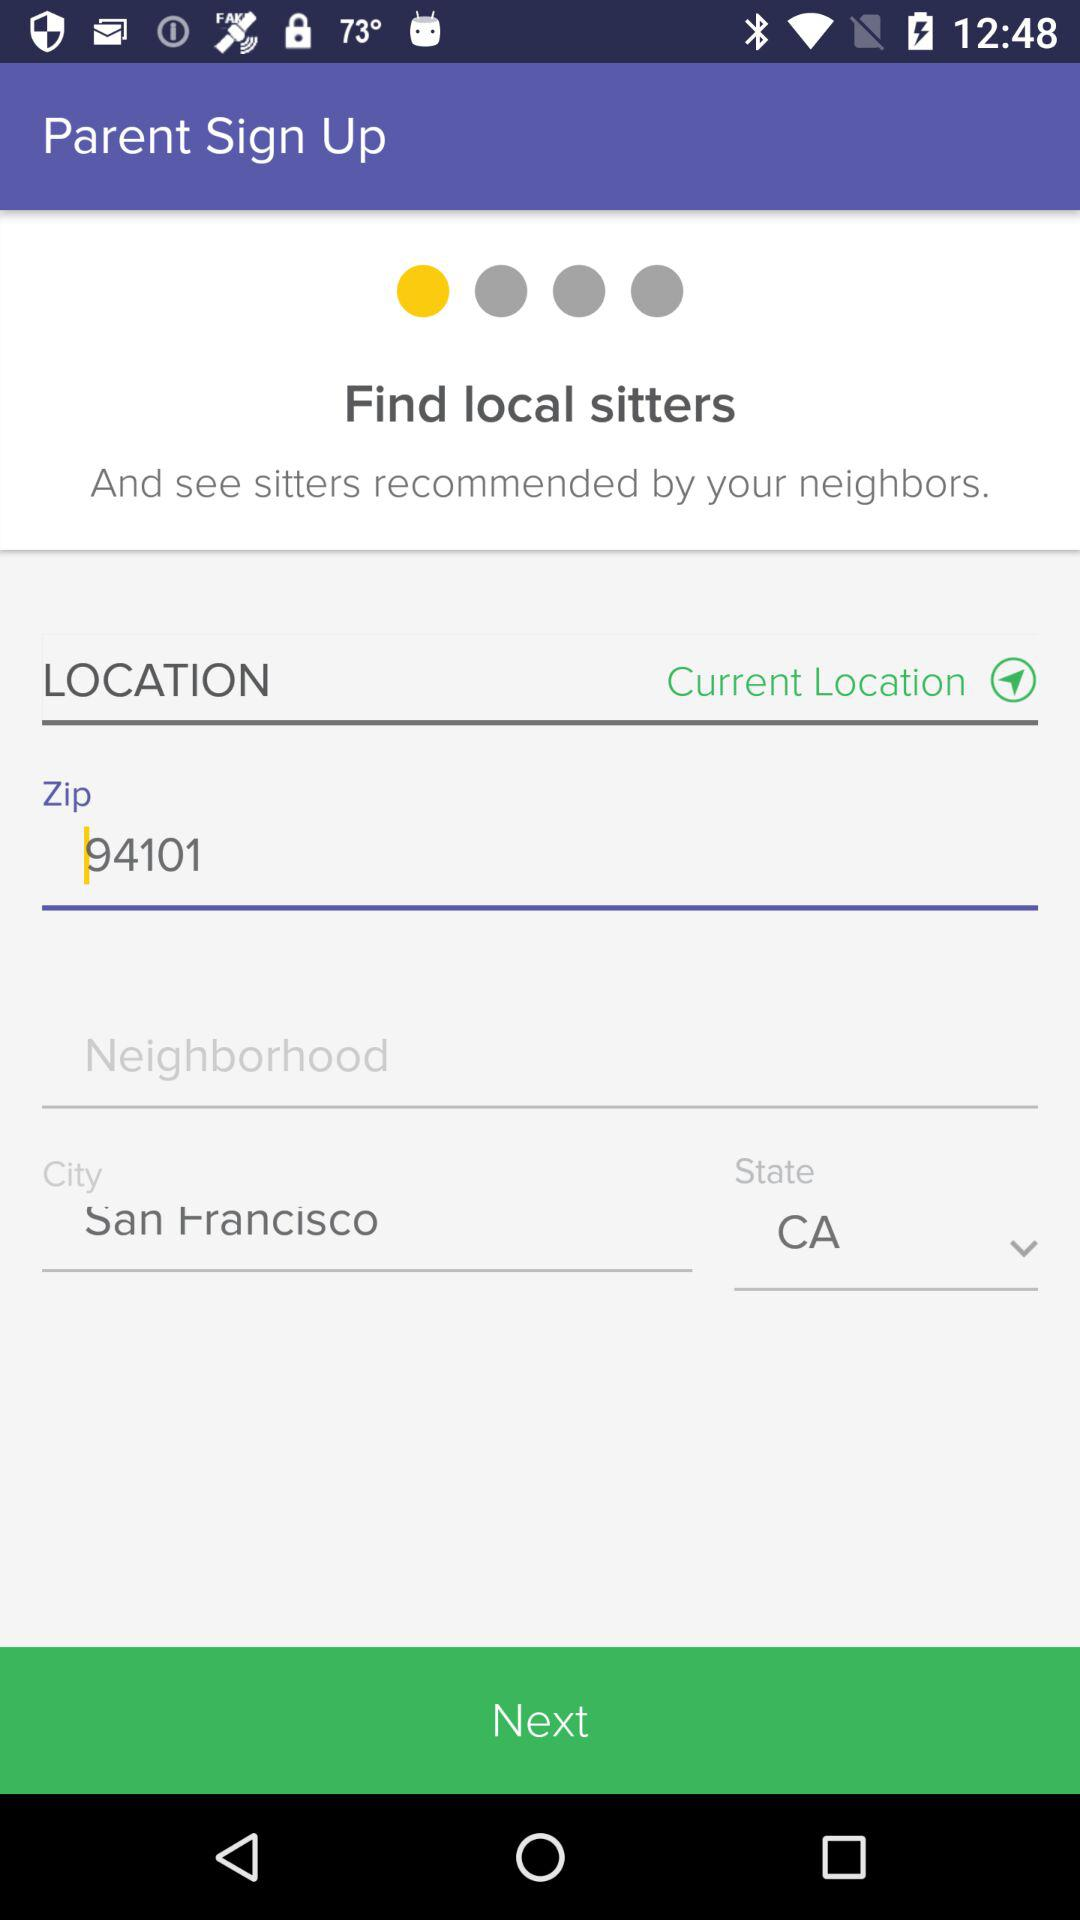What is the given zip code? The given zip code is 94101. 